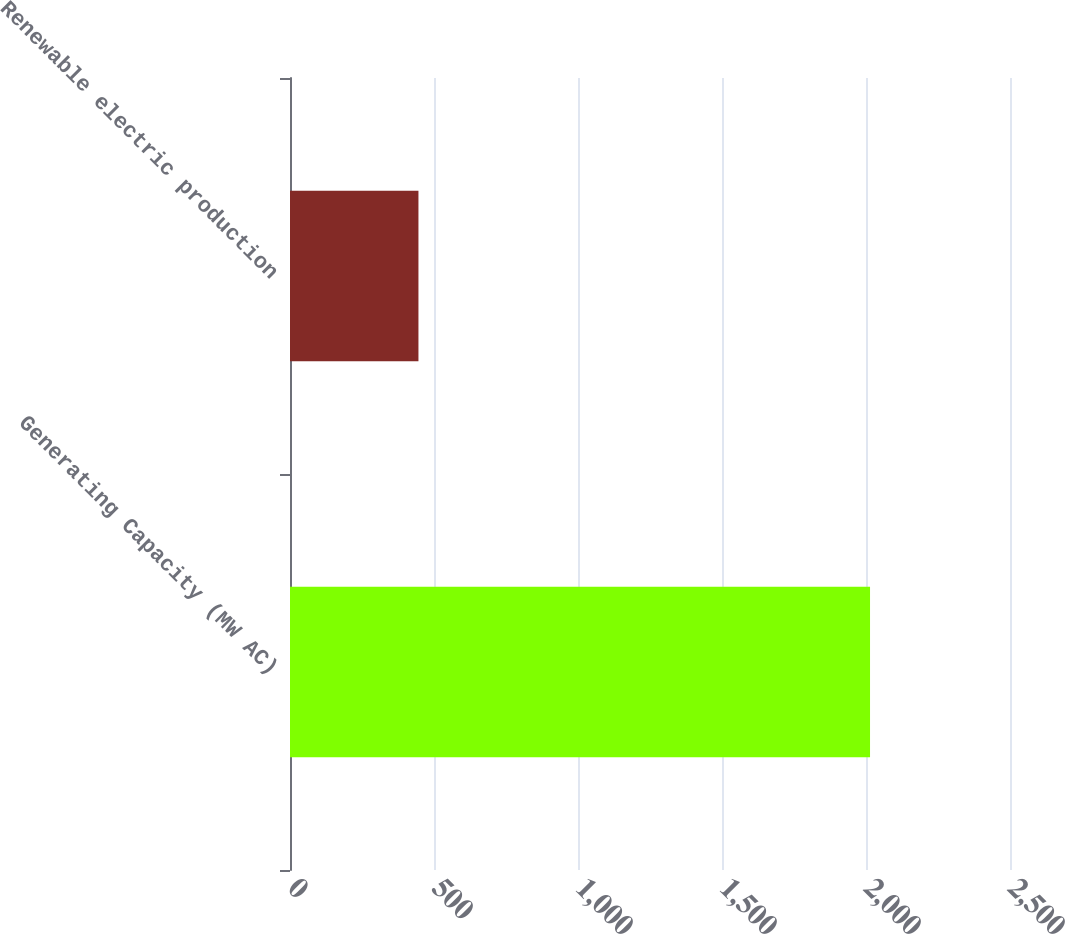Convert chart. <chart><loc_0><loc_0><loc_500><loc_500><bar_chart><fcel>Generating Capacity (MW AC)<fcel>Renewable electric production<nl><fcel>2014<fcel>446<nl></chart> 